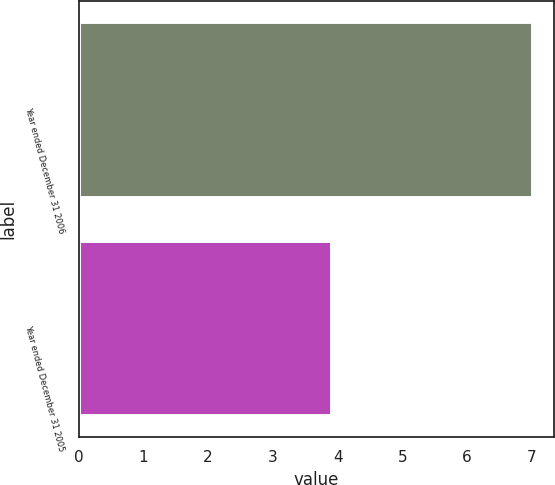Convert chart. <chart><loc_0><loc_0><loc_500><loc_500><bar_chart><fcel>Year ended December 31 2006<fcel>Year ended December 31 2005<nl><fcel>7<fcel>3.9<nl></chart> 